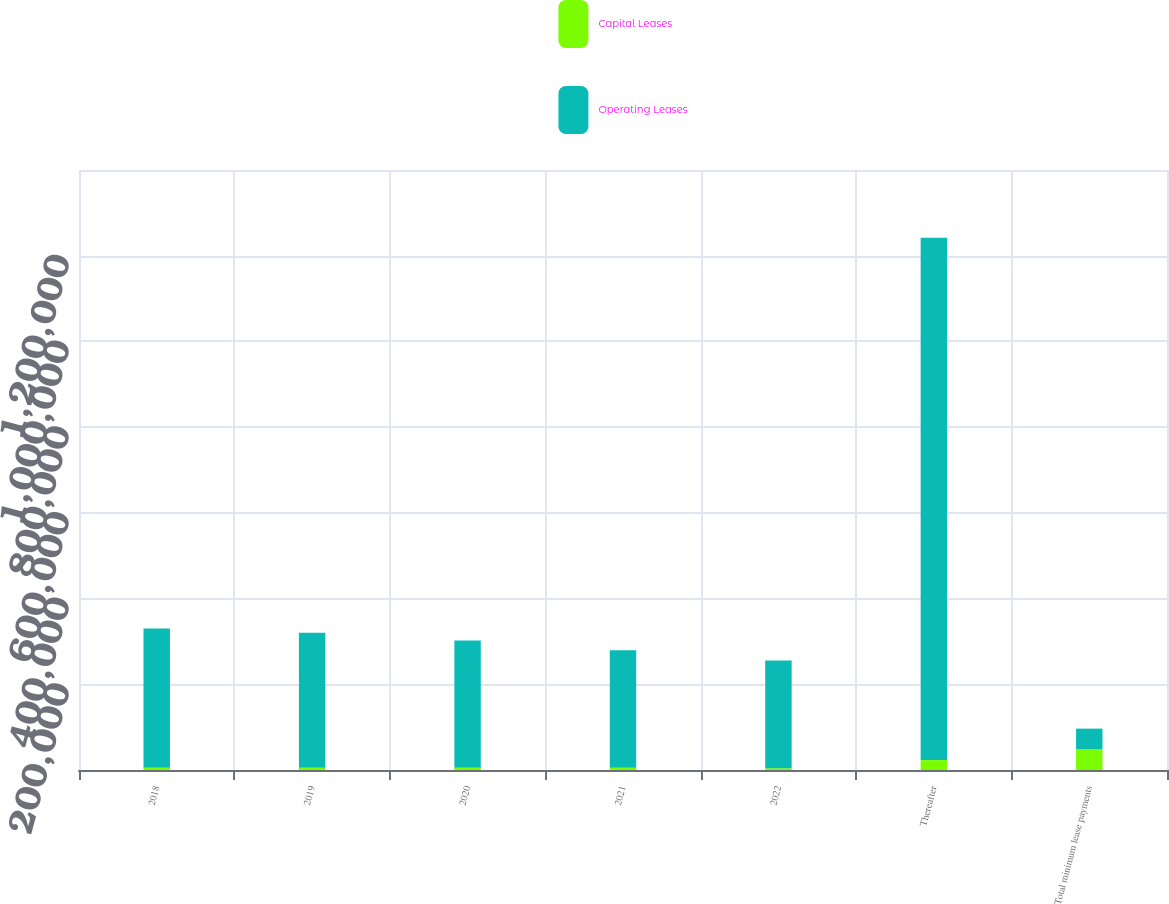Convert chart to OTSL. <chart><loc_0><loc_0><loc_500><loc_500><stacked_bar_chart><ecel><fcel>2018<fcel>2019<fcel>2020<fcel>2021<fcel>2022<fcel>Thereafter<fcel>Total minimum lease payments<nl><fcel>Capital Leases<fcel>5201<fcel>5215<fcel>5234<fcel>5294<fcel>4172<fcel>23149<fcel>48265<nl><fcel>Operating Leases<fcel>324813<fcel>315062<fcel>296773<fcel>273932<fcel>251059<fcel>1.21905e+06<fcel>48265<nl></chart> 